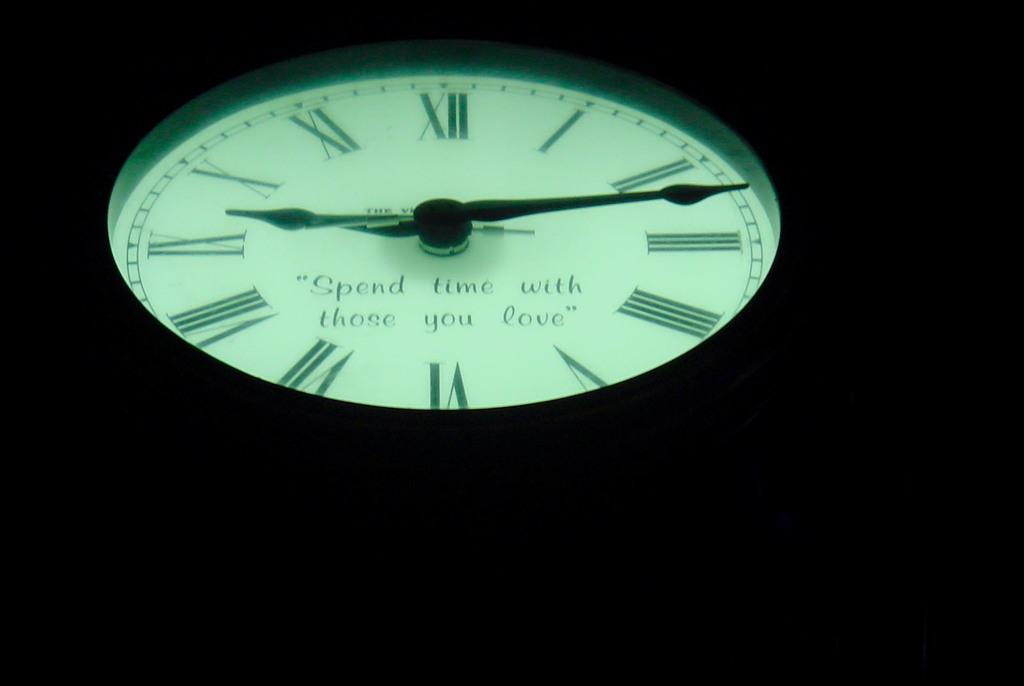<image>
Provide a brief description of the given image. a clock that has roman numerals of one to twelve on it 